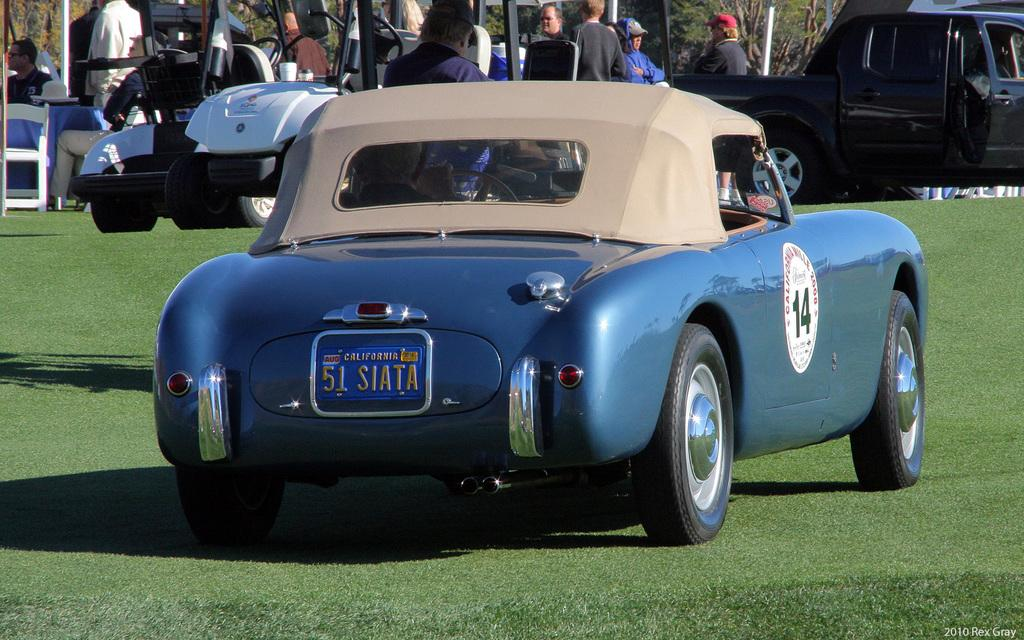What is located in the foreground of the image? There is a car on the grass in the foreground of the image. What can be seen in the background of the image? There are vehicles and men standing and sitting in the background of the image. What type of natural scenery is visible in the background of the image? Trees are visible in the background of the image. How does the image increase the value of the property? The image does not provide any information about the value of the property, so it cannot be determined if it increases or decreases the value. 